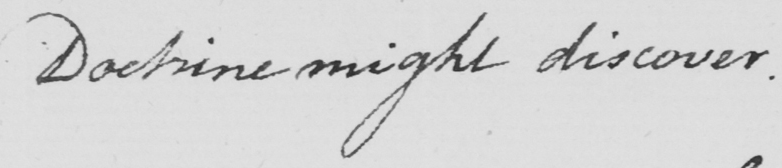Can you read and transcribe this handwriting? Doctrine might discover . 